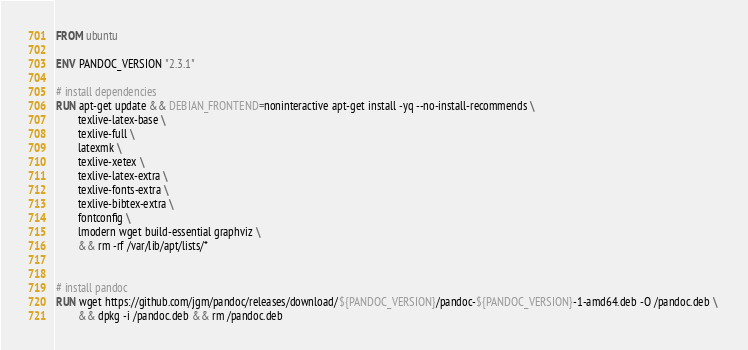Convert code to text. <code><loc_0><loc_0><loc_500><loc_500><_Dockerfile_>FROM ubuntu

ENV PANDOC_VERSION "2.3.1"

# install dependencies
RUN apt-get update && DEBIAN_FRONTEND=noninteractive apt-get install -yq --no-install-recommends \ 
        texlive-latex-base \
        texlive-full \
        latexmk \
        texlive-xetex \
        texlive-latex-extra \
        texlive-fonts-extra \
        texlive-bibtex-extra \
        fontconfig \
        lmodern wget build-essential graphviz \
        && rm -rf /var/lib/apt/lists/*


# install pandoc
RUN wget https://github.com/jgm/pandoc/releases/download/${PANDOC_VERSION}/pandoc-${PANDOC_VERSION}-1-amd64.deb -O /pandoc.deb \ 
        && dpkg -i /pandoc.deb && rm /pandoc.deb
</code> 